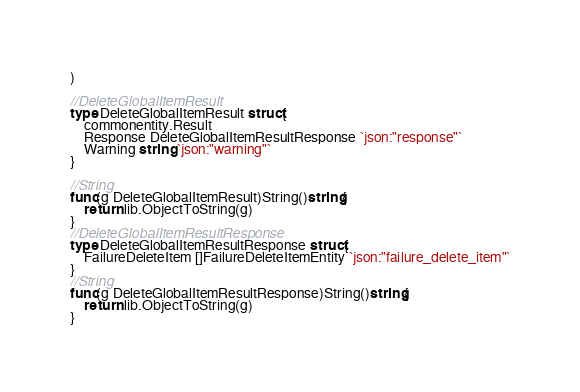Convert code to text. <code><loc_0><loc_0><loc_500><loc_500><_Go_>)

//DeleteGlobalItemResult
type DeleteGlobalItemResult struct{
	commonentity.Result
	Response DeleteGlobalItemResultResponse `json:"response"`
	Warning string `json:"warning"`
}

//String
func(g DeleteGlobalItemResult)String()string{
	return lib.ObjectToString(g)
}
//DeleteGlobalItemResultResponse
type DeleteGlobalItemResultResponse struct{
	FailureDeleteItem []FailureDeleteItemEntity `json:"failure_delete_item"`
}
//String
func(g DeleteGlobalItemResultResponse)String()string{
	return lib.ObjectToString(g)
}</code> 